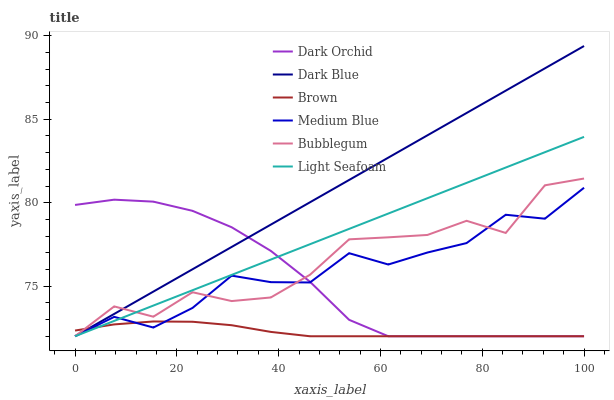Does Brown have the minimum area under the curve?
Answer yes or no. Yes. Does Dark Blue have the maximum area under the curve?
Answer yes or no. Yes. Does Medium Blue have the minimum area under the curve?
Answer yes or no. No. Does Medium Blue have the maximum area under the curve?
Answer yes or no. No. Is Dark Blue the smoothest?
Answer yes or no. Yes. Is Bubblegum the roughest?
Answer yes or no. Yes. Is Medium Blue the smoothest?
Answer yes or no. No. Is Medium Blue the roughest?
Answer yes or no. No. Does Brown have the lowest value?
Answer yes or no. Yes. Does Dark Blue have the highest value?
Answer yes or no. Yes. Does Medium Blue have the highest value?
Answer yes or no. No. Does Light Seafoam intersect Bubblegum?
Answer yes or no. Yes. Is Light Seafoam less than Bubblegum?
Answer yes or no. No. Is Light Seafoam greater than Bubblegum?
Answer yes or no. No. 